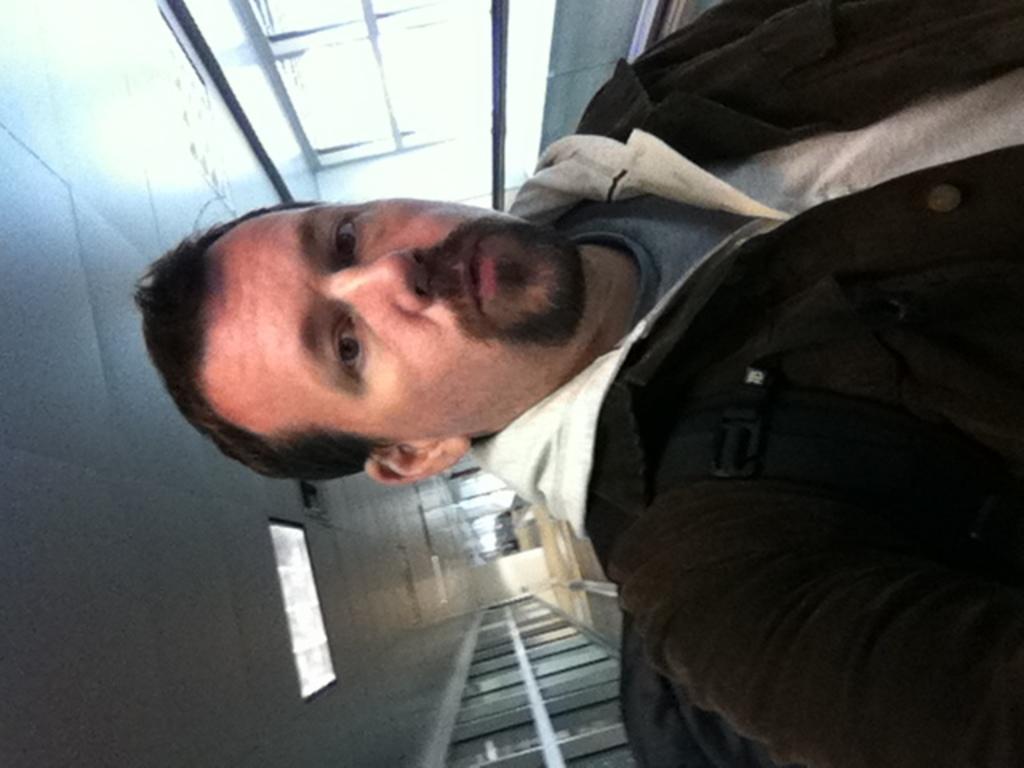In one or two sentences, can you explain what this image depicts? In this picture we can see a man, on top of him we can find a light. 